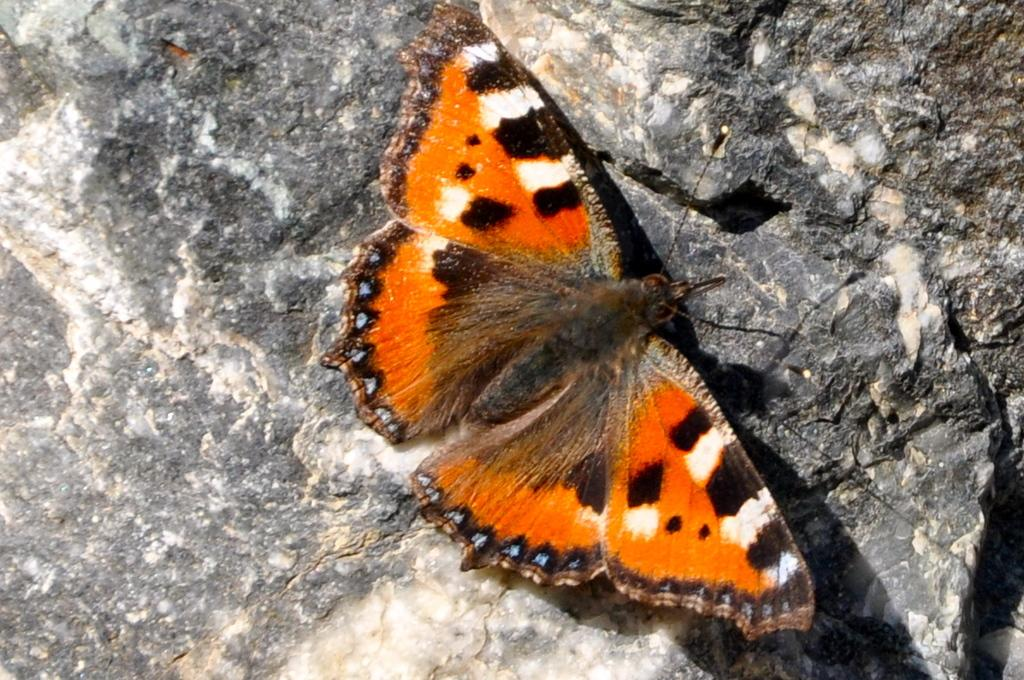What is the main subject of the image? There is a butterfly in the image. Where is the butterfly located? The butterfly is on a rock. What type of calculator is the butterfly using in the image? There is no calculator present in the image; it features a butterfly on a rock. What religious symbol can be seen on the rock in the image? There is no religious symbol present in the image; it features a butterfly on a rock. 